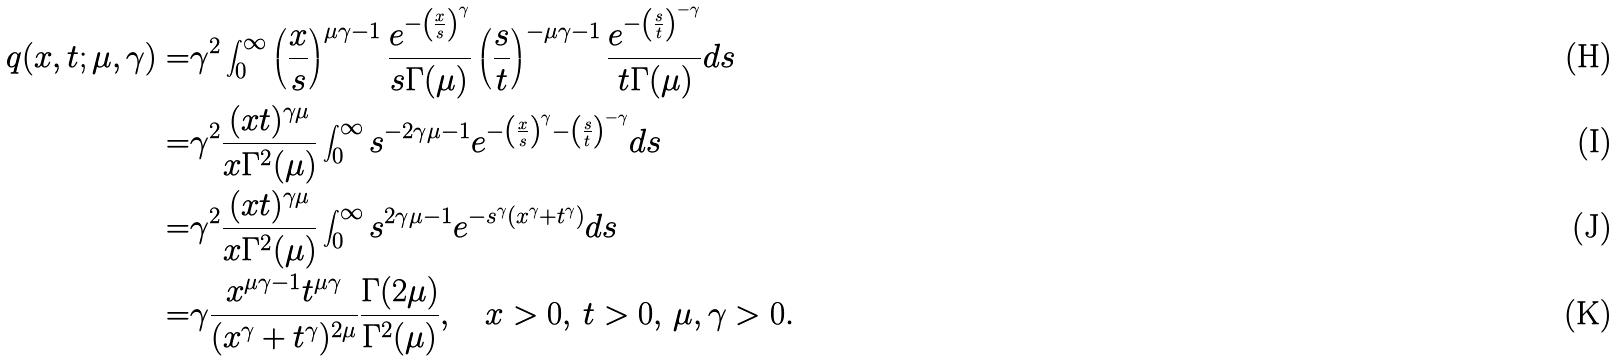Convert formula to latex. <formula><loc_0><loc_0><loc_500><loc_500>q ( x , t ; \mu , \gamma ) = & \gamma ^ { 2 } \int _ { 0 } ^ { \infty } \left ( \frac { x } { s } \right ) ^ { \mu \gamma - 1 } \frac { e ^ { - \left ( \frac { x } { s } \right ) ^ { \gamma } } } { s \Gamma ( \mu ) } \left ( \frac { s } { t } \right ) ^ { - \mu \gamma - 1 } \frac { e ^ { - \left ( \frac { s } { t } \right ) ^ { - \gamma } } } { t \Gamma ( \mu ) } d s \\ = & \gamma ^ { 2 } \frac { ( x t ) ^ { \gamma \mu } } { x \Gamma ^ { 2 } ( \mu ) } \int _ { 0 } ^ { \infty } s ^ { - 2 \gamma \mu - 1 } e ^ { - \left ( \frac { x } { s } \right ) ^ { \gamma } - \left ( \frac { s } { t } \right ) ^ { - \gamma } } d s \\ = & \gamma ^ { 2 } \frac { ( x t ) ^ { \gamma \mu } } { x \Gamma ^ { 2 } ( \mu ) } \int _ { 0 } ^ { \infty } s ^ { 2 \gamma \mu - 1 } e ^ { - s ^ { \gamma } \left ( x ^ { \gamma } + t ^ { \gamma } \right ) } d s \\ = & \gamma \frac { x ^ { \mu \gamma - 1 } t ^ { \mu \gamma } } { ( x ^ { \gamma } + t ^ { \gamma } ) ^ { 2 \mu } } \frac { \Gamma ( 2 \mu ) } { \Gamma ^ { 2 } ( \mu ) } , \quad x > 0 , \, t > 0 , \, \mu , \gamma > 0 .</formula> 